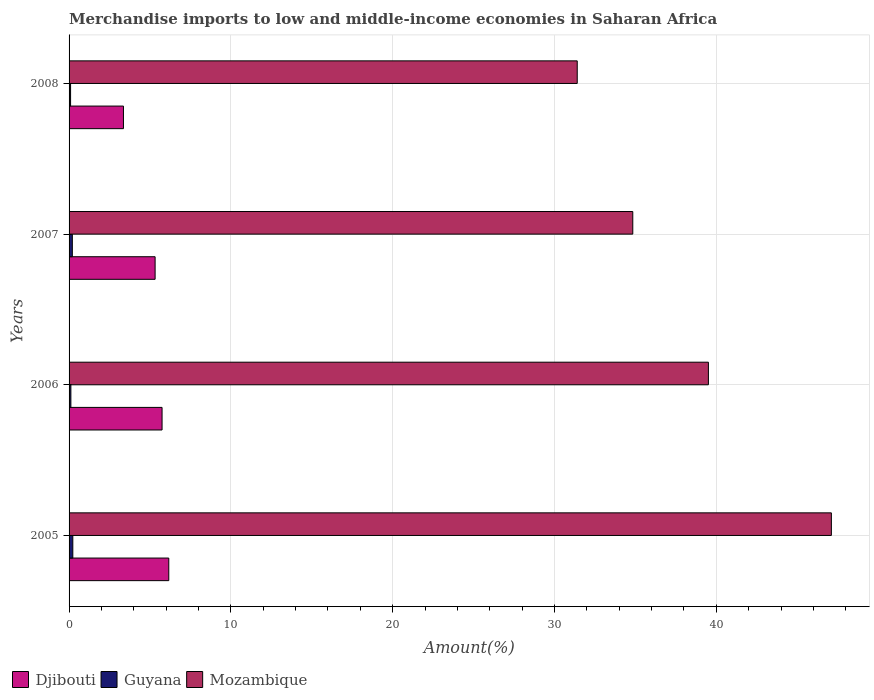How many different coloured bars are there?
Provide a succinct answer. 3. How many groups of bars are there?
Give a very brief answer. 4. Are the number of bars per tick equal to the number of legend labels?
Give a very brief answer. Yes. Are the number of bars on each tick of the Y-axis equal?
Your response must be concise. Yes. How many bars are there on the 3rd tick from the top?
Provide a short and direct response. 3. How many bars are there on the 3rd tick from the bottom?
Keep it short and to the point. 3. What is the label of the 2nd group of bars from the top?
Keep it short and to the point. 2007. In how many cases, is the number of bars for a given year not equal to the number of legend labels?
Give a very brief answer. 0. What is the percentage of amount earned from merchandise imports in Guyana in 2006?
Ensure brevity in your answer.  0.11. Across all years, what is the maximum percentage of amount earned from merchandise imports in Mozambique?
Your answer should be very brief. 47.11. Across all years, what is the minimum percentage of amount earned from merchandise imports in Djibouti?
Provide a succinct answer. 3.36. What is the total percentage of amount earned from merchandise imports in Guyana in the graph?
Ensure brevity in your answer.  0.64. What is the difference between the percentage of amount earned from merchandise imports in Djibouti in 2007 and that in 2008?
Keep it short and to the point. 1.96. What is the difference between the percentage of amount earned from merchandise imports in Djibouti in 2005 and the percentage of amount earned from merchandise imports in Guyana in 2008?
Give a very brief answer. 6.07. What is the average percentage of amount earned from merchandise imports in Djibouti per year?
Provide a short and direct response. 5.15. In the year 2005, what is the difference between the percentage of amount earned from merchandise imports in Mozambique and percentage of amount earned from merchandise imports in Guyana?
Your response must be concise. 46.88. What is the ratio of the percentage of amount earned from merchandise imports in Mozambique in 2007 to that in 2008?
Your answer should be compact. 1.11. Is the difference between the percentage of amount earned from merchandise imports in Mozambique in 2005 and 2008 greater than the difference between the percentage of amount earned from merchandise imports in Guyana in 2005 and 2008?
Keep it short and to the point. Yes. What is the difference between the highest and the second highest percentage of amount earned from merchandise imports in Mozambique?
Give a very brief answer. 7.6. What is the difference between the highest and the lowest percentage of amount earned from merchandise imports in Mozambique?
Offer a very short reply. 15.71. What does the 3rd bar from the top in 2008 represents?
Your answer should be compact. Djibouti. What does the 1st bar from the bottom in 2006 represents?
Provide a succinct answer. Djibouti. Is it the case that in every year, the sum of the percentage of amount earned from merchandise imports in Mozambique and percentage of amount earned from merchandise imports in Guyana is greater than the percentage of amount earned from merchandise imports in Djibouti?
Provide a succinct answer. Yes. Are all the bars in the graph horizontal?
Make the answer very short. Yes. What is the difference between two consecutive major ticks on the X-axis?
Your answer should be compact. 10. Does the graph contain grids?
Your answer should be compact. Yes. Where does the legend appear in the graph?
Offer a very short reply. Bottom left. How many legend labels are there?
Provide a short and direct response. 3. How are the legend labels stacked?
Provide a succinct answer. Horizontal. What is the title of the graph?
Your answer should be very brief. Merchandise imports to low and middle-income economies in Saharan Africa. Does "Kenya" appear as one of the legend labels in the graph?
Your answer should be very brief. No. What is the label or title of the X-axis?
Your response must be concise. Amount(%). What is the Amount(%) of Djibouti in 2005?
Give a very brief answer. 6.16. What is the Amount(%) of Guyana in 2005?
Give a very brief answer. 0.23. What is the Amount(%) in Mozambique in 2005?
Make the answer very short. 47.11. What is the Amount(%) of Djibouti in 2006?
Your response must be concise. 5.75. What is the Amount(%) of Guyana in 2006?
Make the answer very short. 0.11. What is the Amount(%) of Mozambique in 2006?
Offer a terse response. 39.51. What is the Amount(%) of Djibouti in 2007?
Ensure brevity in your answer.  5.32. What is the Amount(%) of Guyana in 2007?
Provide a short and direct response. 0.2. What is the Amount(%) of Mozambique in 2007?
Make the answer very short. 34.84. What is the Amount(%) in Djibouti in 2008?
Keep it short and to the point. 3.36. What is the Amount(%) of Guyana in 2008?
Your answer should be compact. 0.09. What is the Amount(%) of Mozambique in 2008?
Offer a terse response. 31.41. Across all years, what is the maximum Amount(%) of Djibouti?
Ensure brevity in your answer.  6.16. Across all years, what is the maximum Amount(%) in Guyana?
Make the answer very short. 0.23. Across all years, what is the maximum Amount(%) in Mozambique?
Offer a very short reply. 47.11. Across all years, what is the minimum Amount(%) in Djibouti?
Your answer should be very brief. 3.36. Across all years, what is the minimum Amount(%) of Guyana?
Offer a terse response. 0.09. Across all years, what is the minimum Amount(%) of Mozambique?
Provide a succinct answer. 31.41. What is the total Amount(%) of Djibouti in the graph?
Provide a short and direct response. 20.59. What is the total Amount(%) of Guyana in the graph?
Offer a very short reply. 0.64. What is the total Amount(%) in Mozambique in the graph?
Offer a very short reply. 152.87. What is the difference between the Amount(%) in Djibouti in 2005 and that in 2006?
Offer a terse response. 0.41. What is the difference between the Amount(%) of Guyana in 2005 and that in 2006?
Keep it short and to the point. 0.12. What is the difference between the Amount(%) of Mozambique in 2005 and that in 2006?
Give a very brief answer. 7.6. What is the difference between the Amount(%) of Djibouti in 2005 and that in 2007?
Keep it short and to the point. 0.84. What is the difference between the Amount(%) of Guyana in 2005 and that in 2007?
Provide a succinct answer. 0.03. What is the difference between the Amount(%) of Mozambique in 2005 and that in 2007?
Offer a very short reply. 12.27. What is the difference between the Amount(%) of Djibouti in 2005 and that in 2008?
Your response must be concise. 2.8. What is the difference between the Amount(%) of Guyana in 2005 and that in 2008?
Provide a short and direct response. 0.14. What is the difference between the Amount(%) in Mozambique in 2005 and that in 2008?
Make the answer very short. 15.71. What is the difference between the Amount(%) in Djibouti in 2006 and that in 2007?
Your answer should be very brief. 0.43. What is the difference between the Amount(%) in Guyana in 2006 and that in 2007?
Ensure brevity in your answer.  -0.09. What is the difference between the Amount(%) of Mozambique in 2006 and that in 2007?
Provide a short and direct response. 4.67. What is the difference between the Amount(%) in Djibouti in 2006 and that in 2008?
Your response must be concise. 2.39. What is the difference between the Amount(%) in Guyana in 2006 and that in 2008?
Your answer should be compact. 0.02. What is the difference between the Amount(%) in Mozambique in 2006 and that in 2008?
Offer a very short reply. 8.11. What is the difference between the Amount(%) of Djibouti in 2007 and that in 2008?
Make the answer very short. 1.96. What is the difference between the Amount(%) of Guyana in 2007 and that in 2008?
Give a very brief answer. 0.11. What is the difference between the Amount(%) of Mozambique in 2007 and that in 2008?
Your response must be concise. 3.43. What is the difference between the Amount(%) in Djibouti in 2005 and the Amount(%) in Guyana in 2006?
Make the answer very short. 6.05. What is the difference between the Amount(%) in Djibouti in 2005 and the Amount(%) in Mozambique in 2006?
Offer a very short reply. -33.35. What is the difference between the Amount(%) of Guyana in 2005 and the Amount(%) of Mozambique in 2006?
Ensure brevity in your answer.  -39.28. What is the difference between the Amount(%) of Djibouti in 2005 and the Amount(%) of Guyana in 2007?
Provide a succinct answer. 5.96. What is the difference between the Amount(%) of Djibouti in 2005 and the Amount(%) of Mozambique in 2007?
Keep it short and to the point. -28.68. What is the difference between the Amount(%) of Guyana in 2005 and the Amount(%) of Mozambique in 2007?
Ensure brevity in your answer.  -34.61. What is the difference between the Amount(%) of Djibouti in 2005 and the Amount(%) of Guyana in 2008?
Keep it short and to the point. 6.07. What is the difference between the Amount(%) of Djibouti in 2005 and the Amount(%) of Mozambique in 2008?
Offer a terse response. -25.24. What is the difference between the Amount(%) in Guyana in 2005 and the Amount(%) in Mozambique in 2008?
Offer a terse response. -31.18. What is the difference between the Amount(%) of Djibouti in 2006 and the Amount(%) of Guyana in 2007?
Offer a very short reply. 5.55. What is the difference between the Amount(%) of Djibouti in 2006 and the Amount(%) of Mozambique in 2007?
Your answer should be compact. -29.09. What is the difference between the Amount(%) of Guyana in 2006 and the Amount(%) of Mozambique in 2007?
Keep it short and to the point. -34.73. What is the difference between the Amount(%) of Djibouti in 2006 and the Amount(%) of Guyana in 2008?
Offer a terse response. 5.65. What is the difference between the Amount(%) in Djibouti in 2006 and the Amount(%) in Mozambique in 2008?
Provide a short and direct response. -25.66. What is the difference between the Amount(%) of Guyana in 2006 and the Amount(%) of Mozambique in 2008?
Offer a very short reply. -31.29. What is the difference between the Amount(%) in Djibouti in 2007 and the Amount(%) in Guyana in 2008?
Ensure brevity in your answer.  5.22. What is the difference between the Amount(%) in Djibouti in 2007 and the Amount(%) in Mozambique in 2008?
Ensure brevity in your answer.  -26.09. What is the difference between the Amount(%) of Guyana in 2007 and the Amount(%) of Mozambique in 2008?
Give a very brief answer. -31.2. What is the average Amount(%) in Djibouti per year?
Your answer should be compact. 5.15. What is the average Amount(%) in Guyana per year?
Ensure brevity in your answer.  0.16. What is the average Amount(%) of Mozambique per year?
Your response must be concise. 38.22. In the year 2005, what is the difference between the Amount(%) in Djibouti and Amount(%) in Guyana?
Offer a terse response. 5.93. In the year 2005, what is the difference between the Amount(%) in Djibouti and Amount(%) in Mozambique?
Your response must be concise. -40.95. In the year 2005, what is the difference between the Amount(%) in Guyana and Amount(%) in Mozambique?
Your response must be concise. -46.88. In the year 2006, what is the difference between the Amount(%) of Djibouti and Amount(%) of Guyana?
Keep it short and to the point. 5.64. In the year 2006, what is the difference between the Amount(%) of Djibouti and Amount(%) of Mozambique?
Offer a terse response. -33.77. In the year 2006, what is the difference between the Amount(%) of Guyana and Amount(%) of Mozambique?
Provide a succinct answer. -39.4. In the year 2007, what is the difference between the Amount(%) of Djibouti and Amount(%) of Guyana?
Ensure brevity in your answer.  5.12. In the year 2007, what is the difference between the Amount(%) of Djibouti and Amount(%) of Mozambique?
Offer a very short reply. -29.52. In the year 2007, what is the difference between the Amount(%) of Guyana and Amount(%) of Mozambique?
Provide a short and direct response. -34.64. In the year 2008, what is the difference between the Amount(%) of Djibouti and Amount(%) of Guyana?
Your answer should be very brief. 3.27. In the year 2008, what is the difference between the Amount(%) in Djibouti and Amount(%) in Mozambique?
Give a very brief answer. -28.05. In the year 2008, what is the difference between the Amount(%) of Guyana and Amount(%) of Mozambique?
Your answer should be compact. -31.31. What is the ratio of the Amount(%) in Djibouti in 2005 to that in 2006?
Provide a succinct answer. 1.07. What is the ratio of the Amount(%) in Guyana in 2005 to that in 2006?
Keep it short and to the point. 2.08. What is the ratio of the Amount(%) in Mozambique in 2005 to that in 2006?
Give a very brief answer. 1.19. What is the ratio of the Amount(%) in Djibouti in 2005 to that in 2007?
Keep it short and to the point. 1.16. What is the ratio of the Amount(%) in Guyana in 2005 to that in 2007?
Your response must be concise. 1.14. What is the ratio of the Amount(%) in Mozambique in 2005 to that in 2007?
Keep it short and to the point. 1.35. What is the ratio of the Amount(%) in Djibouti in 2005 to that in 2008?
Give a very brief answer. 1.83. What is the ratio of the Amount(%) in Guyana in 2005 to that in 2008?
Provide a short and direct response. 2.48. What is the ratio of the Amount(%) in Mozambique in 2005 to that in 2008?
Offer a very short reply. 1.5. What is the ratio of the Amount(%) in Djibouti in 2006 to that in 2007?
Your answer should be compact. 1.08. What is the ratio of the Amount(%) in Guyana in 2006 to that in 2007?
Offer a terse response. 0.55. What is the ratio of the Amount(%) of Mozambique in 2006 to that in 2007?
Ensure brevity in your answer.  1.13. What is the ratio of the Amount(%) in Djibouti in 2006 to that in 2008?
Ensure brevity in your answer.  1.71. What is the ratio of the Amount(%) of Guyana in 2006 to that in 2008?
Give a very brief answer. 1.19. What is the ratio of the Amount(%) in Mozambique in 2006 to that in 2008?
Offer a terse response. 1.26. What is the ratio of the Amount(%) in Djibouti in 2007 to that in 2008?
Your response must be concise. 1.58. What is the ratio of the Amount(%) of Guyana in 2007 to that in 2008?
Offer a very short reply. 2.17. What is the ratio of the Amount(%) in Mozambique in 2007 to that in 2008?
Your answer should be compact. 1.11. What is the difference between the highest and the second highest Amount(%) of Djibouti?
Your answer should be very brief. 0.41. What is the difference between the highest and the second highest Amount(%) of Guyana?
Ensure brevity in your answer.  0.03. What is the difference between the highest and the second highest Amount(%) in Mozambique?
Keep it short and to the point. 7.6. What is the difference between the highest and the lowest Amount(%) of Djibouti?
Your answer should be compact. 2.8. What is the difference between the highest and the lowest Amount(%) of Guyana?
Ensure brevity in your answer.  0.14. What is the difference between the highest and the lowest Amount(%) in Mozambique?
Your answer should be very brief. 15.71. 